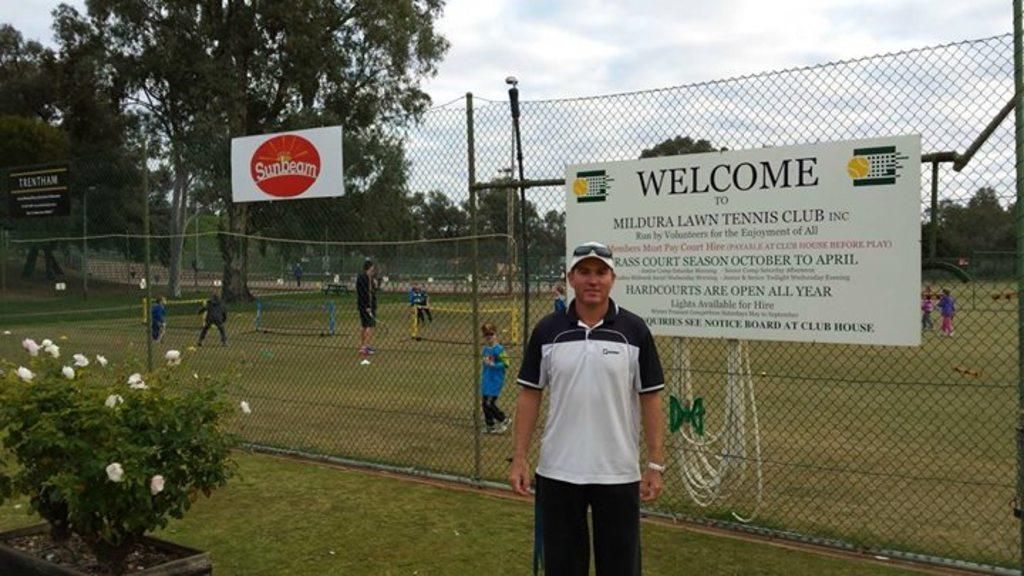<image>
Summarize the visual content of the image. A welcome sign is on a fence next to one with a Sunbeam logo. 